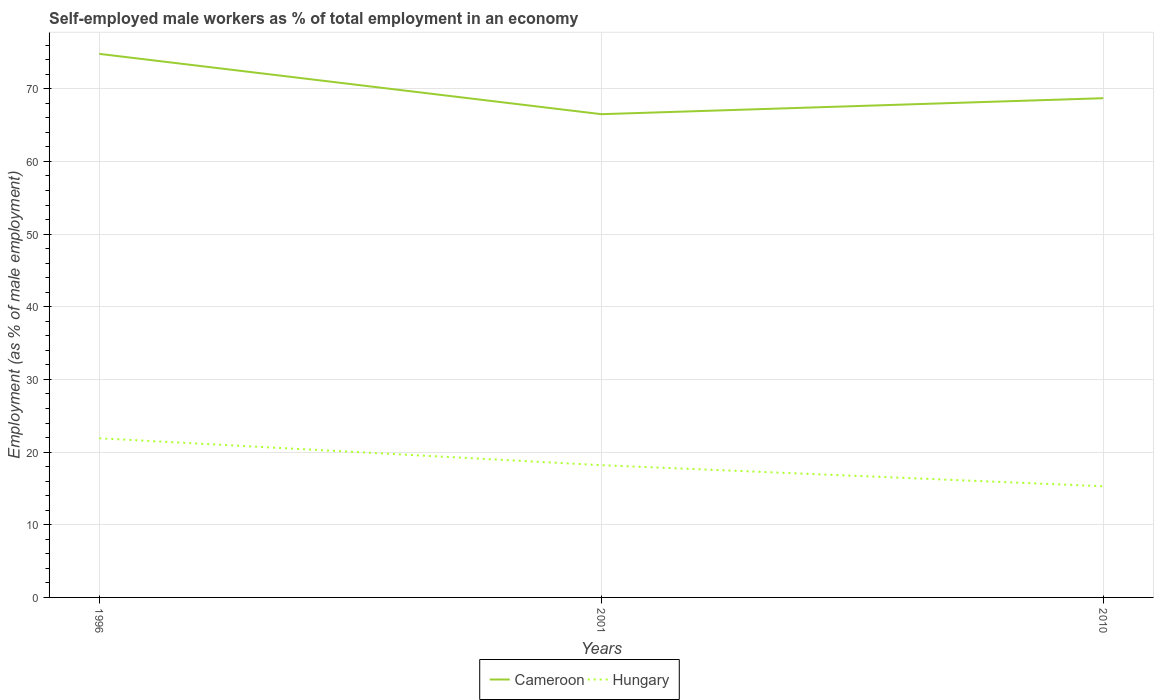How many different coloured lines are there?
Give a very brief answer. 2. Is the number of lines equal to the number of legend labels?
Your response must be concise. Yes. Across all years, what is the maximum percentage of self-employed male workers in Cameroon?
Offer a very short reply. 66.5. In which year was the percentage of self-employed male workers in Hungary maximum?
Your answer should be very brief. 2010. What is the total percentage of self-employed male workers in Cameroon in the graph?
Ensure brevity in your answer.  6.1. What is the difference between the highest and the second highest percentage of self-employed male workers in Cameroon?
Your answer should be compact. 8.3. What is the difference between the highest and the lowest percentage of self-employed male workers in Hungary?
Offer a terse response. 1. Is the percentage of self-employed male workers in Hungary strictly greater than the percentage of self-employed male workers in Cameroon over the years?
Your answer should be very brief. Yes. How many lines are there?
Ensure brevity in your answer.  2. Where does the legend appear in the graph?
Offer a terse response. Bottom center. How are the legend labels stacked?
Ensure brevity in your answer.  Horizontal. What is the title of the graph?
Your answer should be very brief. Self-employed male workers as % of total employment in an economy. What is the label or title of the Y-axis?
Provide a succinct answer. Employment (as % of male employment). What is the Employment (as % of male employment) in Cameroon in 1996?
Offer a very short reply. 74.8. What is the Employment (as % of male employment) in Hungary in 1996?
Offer a very short reply. 21.9. What is the Employment (as % of male employment) of Cameroon in 2001?
Offer a very short reply. 66.5. What is the Employment (as % of male employment) in Hungary in 2001?
Ensure brevity in your answer.  18.2. What is the Employment (as % of male employment) of Cameroon in 2010?
Give a very brief answer. 68.7. What is the Employment (as % of male employment) of Hungary in 2010?
Ensure brevity in your answer.  15.3. Across all years, what is the maximum Employment (as % of male employment) of Cameroon?
Give a very brief answer. 74.8. Across all years, what is the maximum Employment (as % of male employment) in Hungary?
Your response must be concise. 21.9. Across all years, what is the minimum Employment (as % of male employment) of Cameroon?
Give a very brief answer. 66.5. Across all years, what is the minimum Employment (as % of male employment) of Hungary?
Offer a terse response. 15.3. What is the total Employment (as % of male employment) in Cameroon in the graph?
Your answer should be compact. 210. What is the total Employment (as % of male employment) in Hungary in the graph?
Provide a succinct answer. 55.4. What is the difference between the Employment (as % of male employment) in Hungary in 1996 and that in 2001?
Keep it short and to the point. 3.7. What is the difference between the Employment (as % of male employment) in Cameroon in 1996 and that in 2010?
Your response must be concise. 6.1. What is the difference between the Employment (as % of male employment) in Hungary in 1996 and that in 2010?
Give a very brief answer. 6.6. What is the difference between the Employment (as % of male employment) of Cameroon in 2001 and that in 2010?
Offer a terse response. -2.2. What is the difference between the Employment (as % of male employment) of Hungary in 2001 and that in 2010?
Ensure brevity in your answer.  2.9. What is the difference between the Employment (as % of male employment) of Cameroon in 1996 and the Employment (as % of male employment) of Hungary in 2001?
Provide a short and direct response. 56.6. What is the difference between the Employment (as % of male employment) in Cameroon in 1996 and the Employment (as % of male employment) in Hungary in 2010?
Provide a short and direct response. 59.5. What is the difference between the Employment (as % of male employment) in Cameroon in 2001 and the Employment (as % of male employment) in Hungary in 2010?
Provide a succinct answer. 51.2. What is the average Employment (as % of male employment) of Hungary per year?
Keep it short and to the point. 18.47. In the year 1996, what is the difference between the Employment (as % of male employment) of Cameroon and Employment (as % of male employment) of Hungary?
Keep it short and to the point. 52.9. In the year 2001, what is the difference between the Employment (as % of male employment) of Cameroon and Employment (as % of male employment) of Hungary?
Provide a short and direct response. 48.3. In the year 2010, what is the difference between the Employment (as % of male employment) in Cameroon and Employment (as % of male employment) in Hungary?
Your answer should be compact. 53.4. What is the ratio of the Employment (as % of male employment) of Cameroon in 1996 to that in 2001?
Keep it short and to the point. 1.12. What is the ratio of the Employment (as % of male employment) in Hungary in 1996 to that in 2001?
Your answer should be very brief. 1.2. What is the ratio of the Employment (as % of male employment) of Cameroon in 1996 to that in 2010?
Provide a short and direct response. 1.09. What is the ratio of the Employment (as % of male employment) in Hungary in 1996 to that in 2010?
Give a very brief answer. 1.43. What is the ratio of the Employment (as % of male employment) in Hungary in 2001 to that in 2010?
Provide a short and direct response. 1.19. What is the difference between the highest and the lowest Employment (as % of male employment) of Hungary?
Your answer should be very brief. 6.6. 